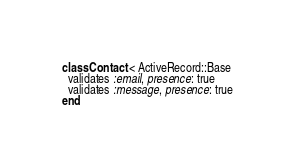<code> <loc_0><loc_0><loc_500><loc_500><_Ruby_>class Contact < ActiveRecord::Base
  validates :email, presence: true
  validates :message, presence: true
end
</code> 